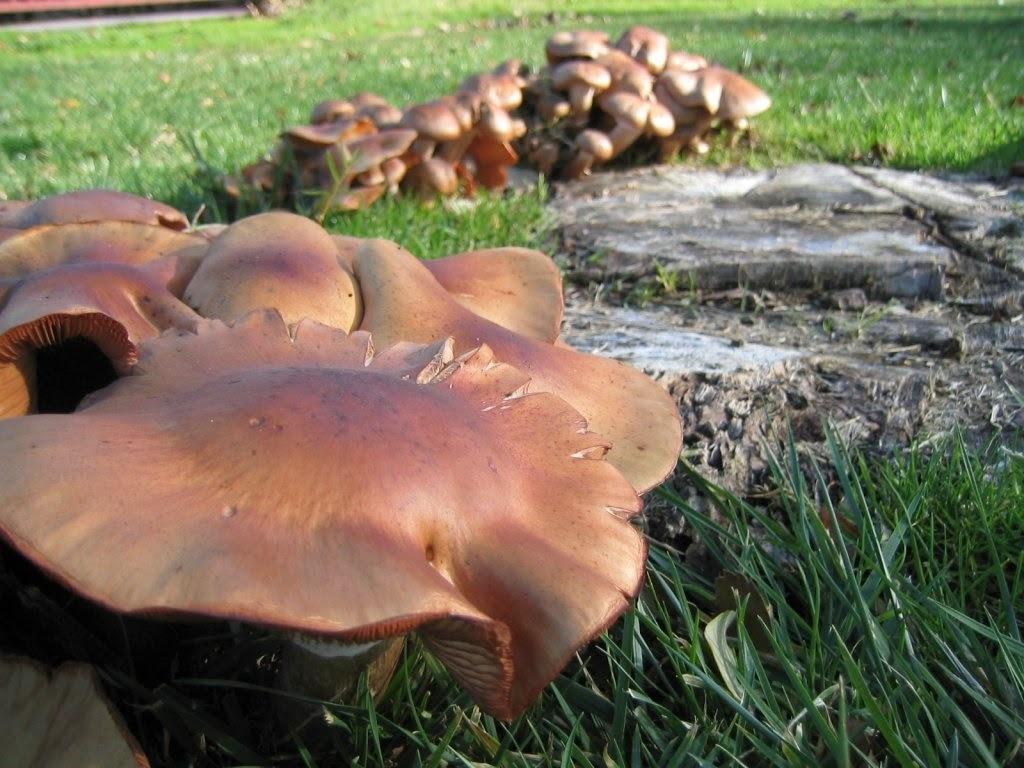How would you summarize this image in a sentence or two? In this image there are mushroom in a grassland. 